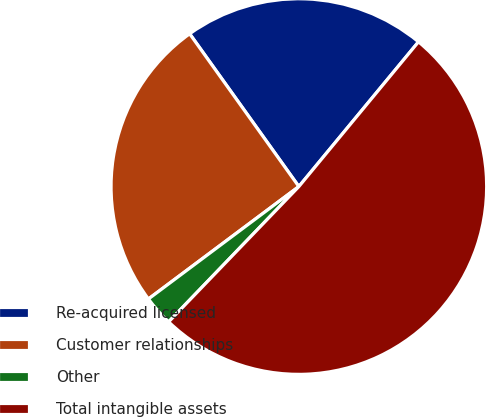Convert chart. <chart><loc_0><loc_0><loc_500><loc_500><pie_chart><fcel>Re-acquired licensed<fcel>Customer relationships<fcel>Other<fcel>Total intangible assets<nl><fcel>20.87%<fcel>25.34%<fcel>2.59%<fcel>51.2%<nl></chart> 